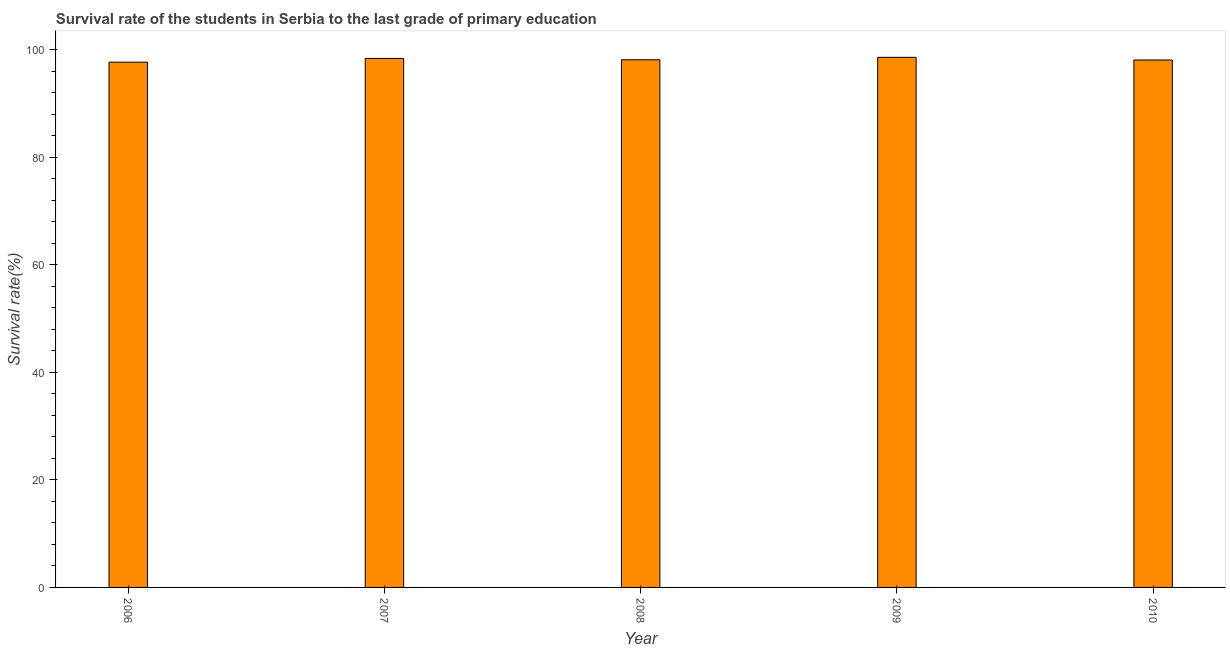Does the graph contain grids?
Ensure brevity in your answer.  No. What is the title of the graph?
Offer a terse response. Survival rate of the students in Serbia to the last grade of primary education. What is the label or title of the X-axis?
Your response must be concise. Year. What is the label or title of the Y-axis?
Provide a succinct answer. Survival rate(%). What is the survival rate in primary education in 2006?
Your response must be concise. 97.66. Across all years, what is the maximum survival rate in primary education?
Provide a short and direct response. 98.56. Across all years, what is the minimum survival rate in primary education?
Your response must be concise. 97.66. In which year was the survival rate in primary education minimum?
Your answer should be very brief. 2006. What is the sum of the survival rate in primary education?
Offer a terse response. 490.76. What is the difference between the survival rate in primary education in 2006 and 2007?
Offer a very short reply. -0.7. What is the average survival rate in primary education per year?
Ensure brevity in your answer.  98.15. What is the median survival rate in primary education?
Give a very brief answer. 98.11. In how many years, is the survival rate in primary education greater than 64 %?
Ensure brevity in your answer.  5. Is the difference between the survival rate in primary education in 2007 and 2009 greater than the difference between any two years?
Your answer should be very brief. No. What is the difference between the highest and the second highest survival rate in primary education?
Your answer should be compact. 0.2. Is the sum of the survival rate in primary education in 2007 and 2008 greater than the maximum survival rate in primary education across all years?
Give a very brief answer. Yes. In how many years, is the survival rate in primary education greater than the average survival rate in primary education taken over all years?
Your answer should be very brief. 2. How many bars are there?
Offer a terse response. 5. What is the difference between two consecutive major ticks on the Y-axis?
Keep it short and to the point. 20. What is the Survival rate(%) in 2006?
Your response must be concise. 97.66. What is the Survival rate(%) in 2007?
Offer a terse response. 98.36. What is the Survival rate(%) in 2008?
Keep it short and to the point. 98.11. What is the Survival rate(%) of 2009?
Your answer should be compact. 98.56. What is the Survival rate(%) in 2010?
Your response must be concise. 98.07. What is the difference between the Survival rate(%) in 2006 and 2007?
Give a very brief answer. -0.7. What is the difference between the Survival rate(%) in 2006 and 2008?
Ensure brevity in your answer.  -0.45. What is the difference between the Survival rate(%) in 2006 and 2009?
Your response must be concise. -0.9. What is the difference between the Survival rate(%) in 2006 and 2010?
Provide a succinct answer. -0.4. What is the difference between the Survival rate(%) in 2007 and 2008?
Offer a very short reply. 0.25. What is the difference between the Survival rate(%) in 2007 and 2009?
Make the answer very short. -0.2. What is the difference between the Survival rate(%) in 2007 and 2010?
Provide a succinct answer. 0.29. What is the difference between the Survival rate(%) in 2008 and 2009?
Ensure brevity in your answer.  -0.45. What is the difference between the Survival rate(%) in 2008 and 2010?
Offer a very short reply. 0.04. What is the difference between the Survival rate(%) in 2009 and 2010?
Your answer should be very brief. 0.5. What is the ratio of the Survival rate(%) in 2006 to that in 2007?
Ensure brevity in your answer.  0.99. What is the ratio of the Survival rate(%) in 2006 to that in 2009?
Make the answer very short. 0.99. What is the ratio of the Survival rate(%) in 2006 to that in 2010?
Offer a very short reply. 1. What is the ratio of the Survival rate(%) in 2007 to that in 2008?
Your response must be concise. 1. What is the ratio of the Survival rate(%) in 2008 to that in 2009?
Your response must be concise. 0.99. What is the ratio of the Survival rate(%) in 2008 to that in 2010?
Keep it short and to the point. 1. What is the ratio of the Survival rate(%) in 2009 to that in 2010?
Provide a short and direct response. 1. 